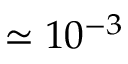<formula> <loc_0><loc_0><loc_500><loc_500>\simeq 1 0 ^ { - 3 }</formula> 